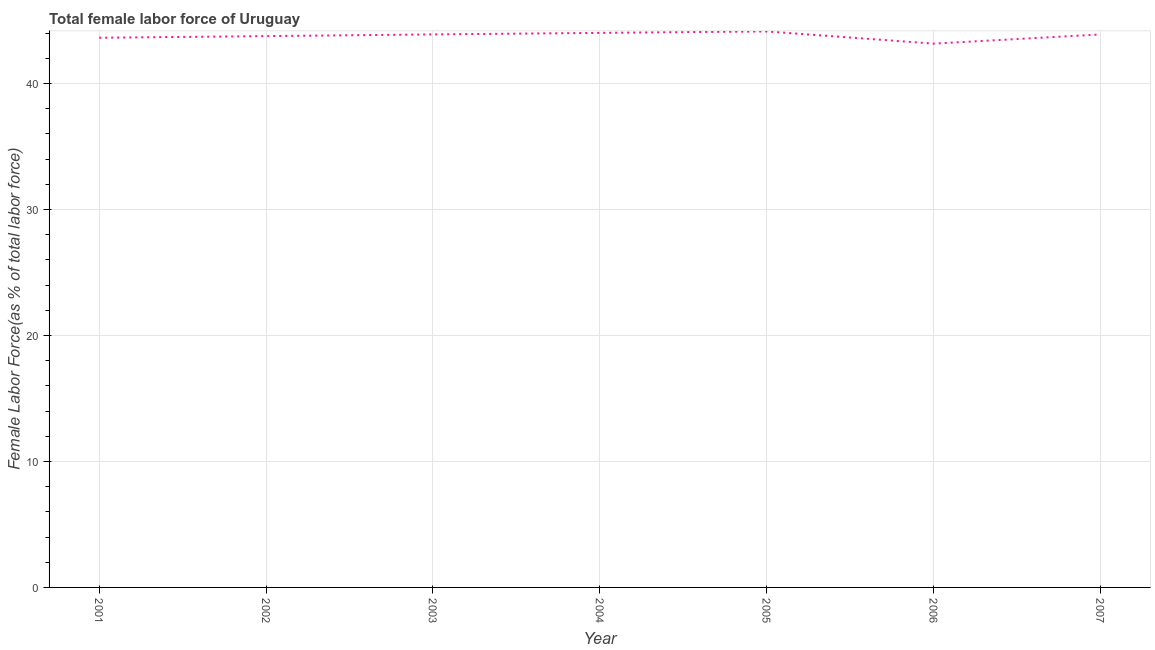What is the total female labor force in 2006?
Provide a succinct answer. 43.17. Across all years, what is the maximum total female labor force?
Provide a succinct answer. 44.13. Across all years, what is the minimum total female labor force?
Your answer should be very brief. 43.17. In which year was the total female labor force minimum?
Provide a short and direct response. 2006. What is the sum of the total female labor force?
Your answer should be very brief. 306.5. What is the difference between the total female labor force in 2001 and 2002?
Ensure brevity in your answer.  -0.13. What is the average total female labor force per year?
Make the answer very short. 43.79. What is the median total female labor force?
Keep it short and to the point. 43.9. In how many years, is the total female labor force greater than 6 %?
Give a very brief answer. 7. Do a majority of the years between 2003 and 2007 (inclusive) have total female labor force greater than 32 %?
Your response must be concise. Yes. What is the ratio of the total female labor force in 2002 to that in 2006?
Your response must be concise. 1.01. Is the total female labor force in 2005 less than that in 2006?
Give a very brief answer. No. Is the difference between the total female labor force in 2005 and 2007 greater than the difference between any two years?
Make the answer very short. No. What is the difference between the highest and the second highest total female labor force?
Offer a very short reply. 0.12. What is the difference between the highest and the lowest total female labor force?
Offer a terse response. 0.97. In how many years, is the total female labor force greater than the average total female labor force taken over all years?
Give a very brief answer. 4. Does the total female labor force monotonically increase over the years?
Ensure brevity in your answer.  No. What is the difference between two consecutive major ticks on the Y-axis?
Keep it short and to the point. 10. What is the title of the graph?
Your response must be concise. Total female labor force of Uruguay. What is the label or title of the Y-axis?
Your answer should be compact. Female Labor Force(as % of total labor force). What is the Female Labor Force(as % of total labor force) of 2001?
Give a very brief answer. 43.63. What is the Female Labor Force(as % of total labor force) in 2002?
Your answer should be compact. 43.76. What is the Female Labor Force(as % of total labor force) of 2003?
Offer a very short reply. 43.9. What is the Female Labor Force(as % of total labor force) of 2004?
Give a very brief answer. 44.02. What is the Female Labor Force(as % of total labor force) of 2005?
Offer a terse response. 44.13. What is the Female Labor Force(as % of total labor force) in 2006?
Provide a short and direct response. 43.17. What is the Female Labor Force(as % of total labor force) of 2007?
Offer a terse response. 43.9. What is the difference between the Female Labor Force(as % of total labor force) in 2001 and 2002?
Keep it short and to the point. -0.13. What is the difference between the Female Labor Force(as % of total labor force) in 2001 and 2003?
Offer a terse response. -0.27. What is the difference between the Female Labor Force(as % of total labor force) in 2001 and 2004?
Make the answer very short. -0.39. What is the difference between the Female Labor Force(as % of total labor force) in 2001 and 2005?
Make the answer very short. -0.5. What is the difference between the Female Labor Force(as % of total labor force) in 2001 and 2006?
Provide a short and direct response. 0.47. What is the difference between the Female Labor Force(as % of total labor force) in 2001 and 2007?
Provide a short and direct response. -0.26. What is the difference between the Female Labor Force(as % of total labor force) in 2002 and 2003?
Offer a very short reply. -0.14. What is the difference between the Female Labor Force(as % of total labor force) in 2002 and 2004?
Make the answer very short. -0.26. What is the difference between the Female Labor Force(as % of total labor force) in 2002 and 2005?
Your response must be concise. -0.37. What is the difference between the Female Labor Force(as % of total labor force) in 2002 and 2006?
Give a very brief answer. 0.6. What is the difference between the Female Labor Force(as % of total labor force) in 2002 and 2007?
Your response must be concise. -0.13. What is the difference between the Female Labor Force(as % of total labor force) in 2003 and 2004?
Your answer should be very brief. -0.12. What is the difference between the Female Labor Force(as % of total labor force) in 2003 and 2005?
Offer a very short reply. -0.24. What is the difference between the Female Labor Force(as % of total labor force) in 2003 and 2006?
Provide a succinct answer. 0.73. What is the difference between the Female Labor Force(as % of total labor force) in 2003 and 2007?
Ensure brevity in your answer.  0. What is the difference between the Female Labor Force(as % of total labor force) in 2004 and 2005?
Ensure brevity in your answer.  -0.12. What is the difference between the Female Labor Force(as % of total labor force) in 2004 and 2006?
Offer a terse response. 0.85. What is the difference between the Female Labor Force(as % of total labor force) in 2004 and 2007?
Your answer should be very brief. 0.12. What is the difference between the Female Labor Force(as % of total labor force) in 2005 and 2006?
Offer a terse response. 0.97. What is the difference between the Female Labor Force(as % of total labor force) in 2005 and 2007?
Provide a short and direct response. 0.24. What is the difference between the Female Labor Force(as % of total labor force) in 2006 and 2007?
Your response must be concise. -0.73. What is the ratio of the Female Labor Force(as % of total labor force) in 2001 to that in 2003?
Provide a short and direct response. 0.99. What is the ratio of the Female Labor Force(as % of total labor force) in 2001 to that in 2006?
Your answer should be very brief. 1.01. What is the ratio of the Female Labor Force(as % of total labor force) in 2002 to that in 2005?
Your response must be concise. 0.99. What is the ratio of the Female Labor Force(as % of total labor force) in 2003 to that in 2005?
Offer a very short reply. 0.99. What is the ratio of the Female Labor Force(as % of total labor force) in 2003 to that in 2006?
Provide a succinct answer. 1.02. What is the ratio of the Female Labor Force(as % of total labor force) in 2004 to that in 2006?
Your response must be concise. 1.02. What is the ratio of the Female Labor Force(as % of total labor force) in 2005 to that in 2006?
Keep it short and to the point. 1.02. What is the ratio of the Female Labor Force(as % of total labor force) in 2005 to that in 2007?
Keep it short and to the point. 1. What is the ratio of the Female Labor Force(as % of total labor force) in 2006 to that in 2007?
Your answer should be very brief. 0.98. 